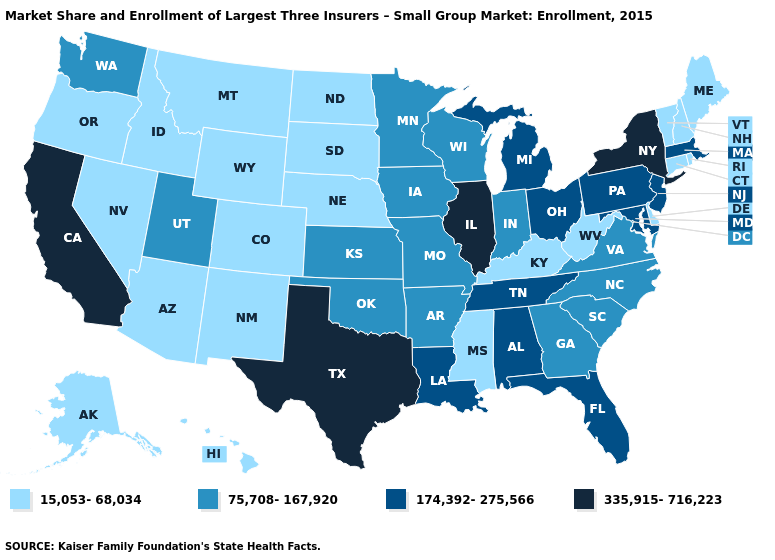What is the value of New Jersey?
Short answer required. 174,392-275,566. Name the states that have a value in the range 174,392-275,566?
Short answer required. Alabama, Florida, Louisiana, Maryland, Massachusetts, Michigan, New Jersey, Ohio, Pennsylvania, Tennessee. Is the legend a continuous bar?
Give a very brief answer. No. What is the value of Louisiana?
Short answer required. 174,392-275,566. What is the value of Colorado?
Quick response, please. 15,053-68,034. What is the highest value in the South ?
Quick response, please. 335,915-716,223. What is the value of Oklahoma?
Give a very brief answer. 75,708-167,920. What is the value of Illinois?
Give a very brief answer. 335,915-716,223. Does New Hampshire have the lowest value in the USA?
Answer briefly. Yes. Among the states that border Massachusetts , does Connecticut have the lowest value?
Short answer required. Yes. Does California have the highest value in the USA?
Write a very short answer. Yes. Does Tennessee have a lower value than New York?
Concise answer only. Yes. Name the states that have a value in the range 174,392-275,566?
Answer briefly. Alabama, Florida, Louisiana, Maryland, Massachusetts, Michigan, New Jersey, Ohio, Pennsylvania, Tennessee. Which states have the lowest value in the West?
Be succinct. Alaska, Arizona, Colorado, Hawaii, Idaho, Montana, Nevada, New Mexico, Oregon, Wyoming. What is the value of Arizona?
Quick response, please. 15,053-68,034. 